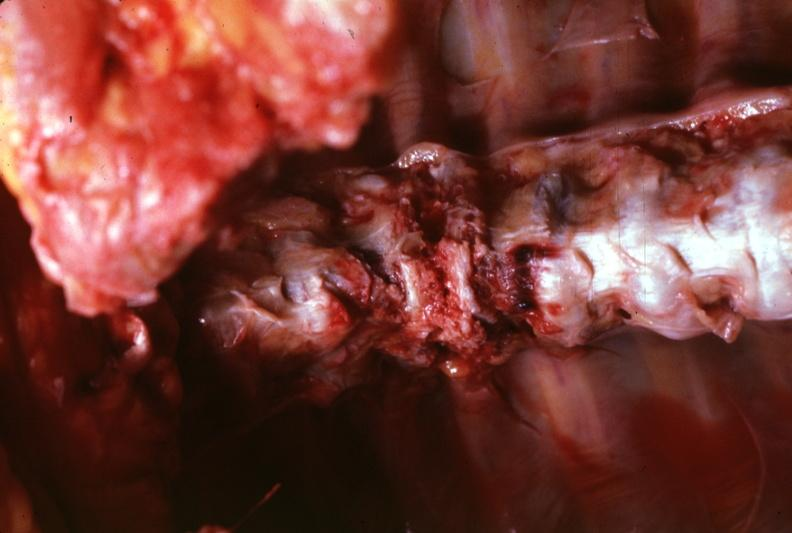how is view of spinal column shown situ shown rather close-up quite?
Answer the question using a single word or phrase. Good 